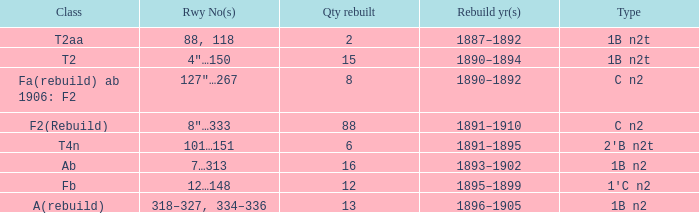What is the total of quantity rebuilt if the type is 1B N2T and the railway number is 88, 118? 1.0. 